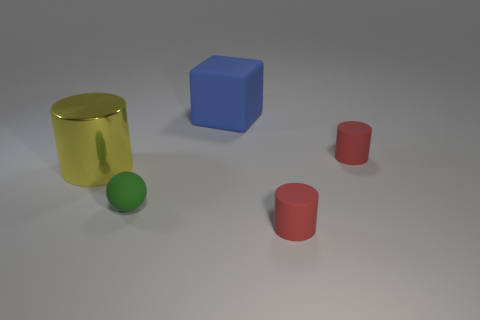What might be the purpose of arranging these objects in this manner? The arrangement could be part of a visual study in composition and lighting, often used in art and design education to teach about form, color contrast, and shadow casting. Alternatively, it might be a simple demonstration of 3D modeling and rendering techniques. 